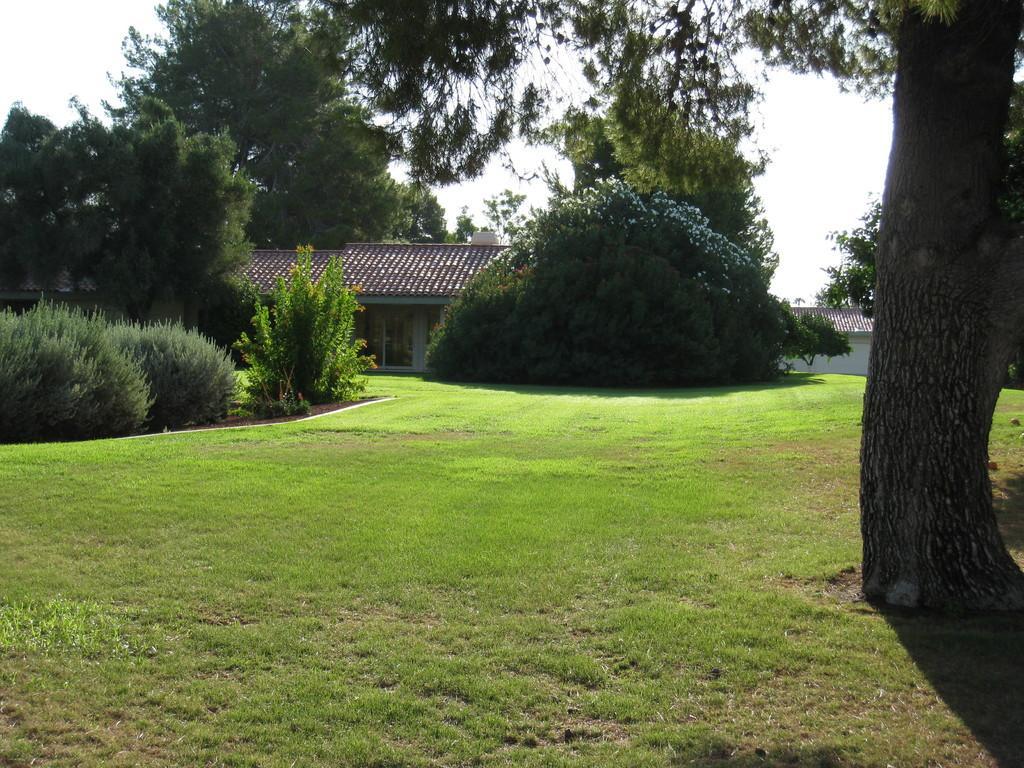Can you describe this image briefly? This image consists of a house. At the bottom, there is green grass. On the left and right, there are trees. At the top, there is sky. 